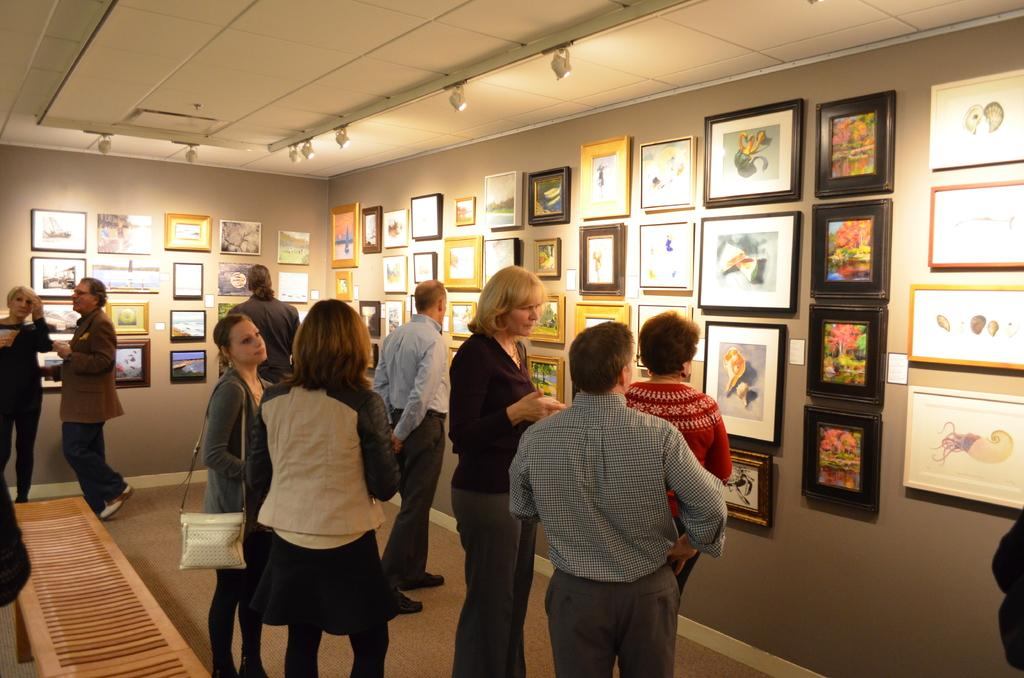How many people are in the image? There are people in the image, but the exact number is not specified. What is one person doing in the image? One person is carrying a bag. What can be seen on the wall in the image? There are frames on the wall. What type of seating is present in the image? There is a bench in the image. What is visible at the top of the image? Lights are visible at the top of the image. Can you see any caves in the image? There is no mention of a cave in the image, so it cannot be seen. 